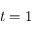<formula> <loc_0><loc_0><loc_500><loc_500>t = 1</formula> 